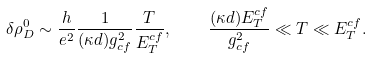<formula> <loc_0><loc_0><loc_500><loc_500>\delta \rho _ { D } ^ { 0 } \sim \frac { h } { e ^ { 2 } } \frac { 1 } { ( \kappa d ) g _ { c f } ^ { 2 } } \frac { T } { E _ { T } ^ { c f } } , \quad \frac { ( \kappa d ) E _ { T } ^ { c f } } { g _ { c f } ^ { 2 } } \ll T \ll E _ { T } ^ { c f } .</formula> 